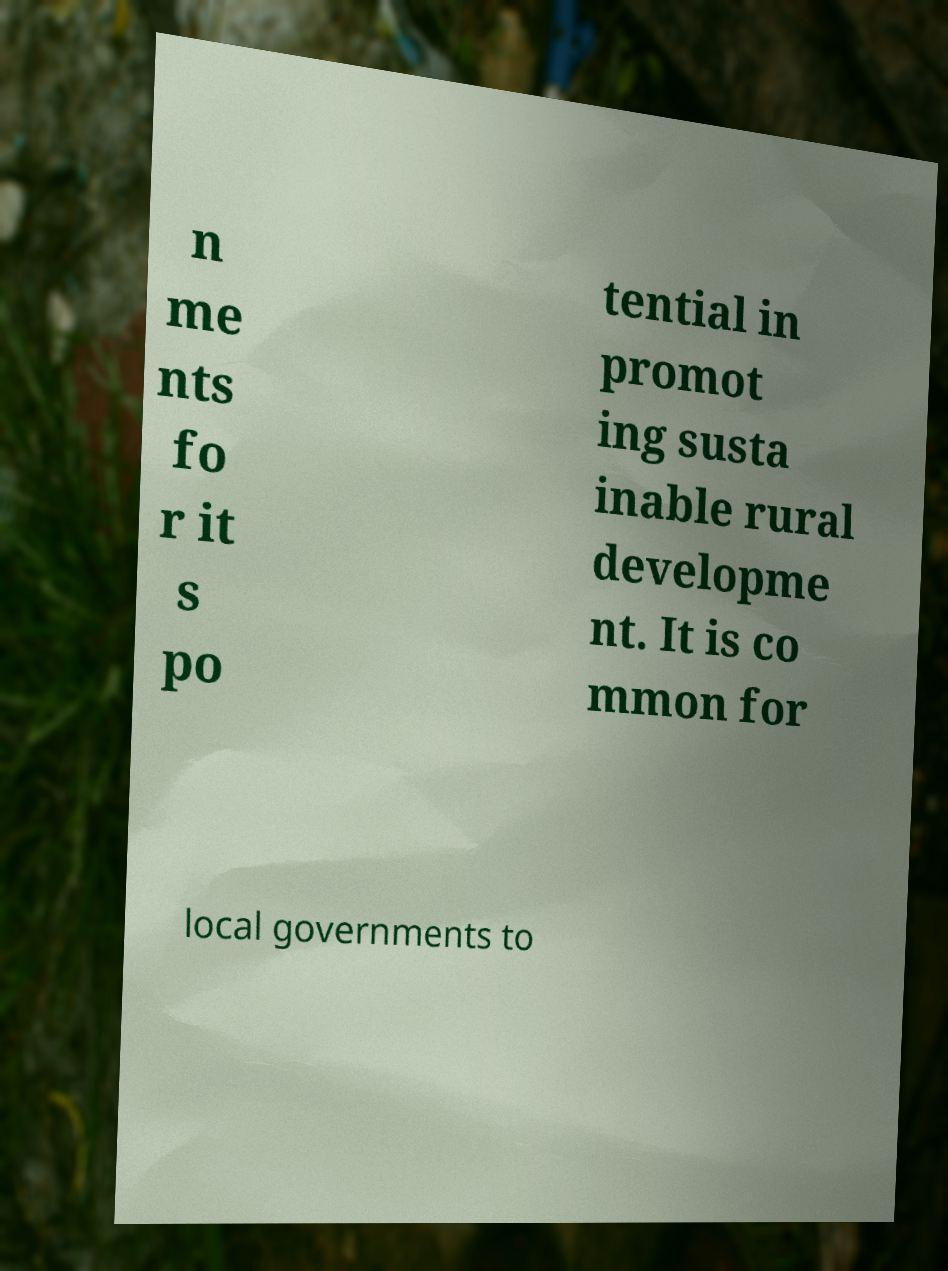Can you accurately transcribe the text from the provided image for me? n me nts fo r it s po tential in promot ing susta inable rural developme nt. It is co mmon for local governments to 